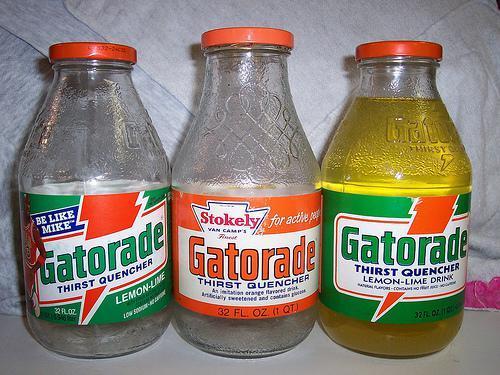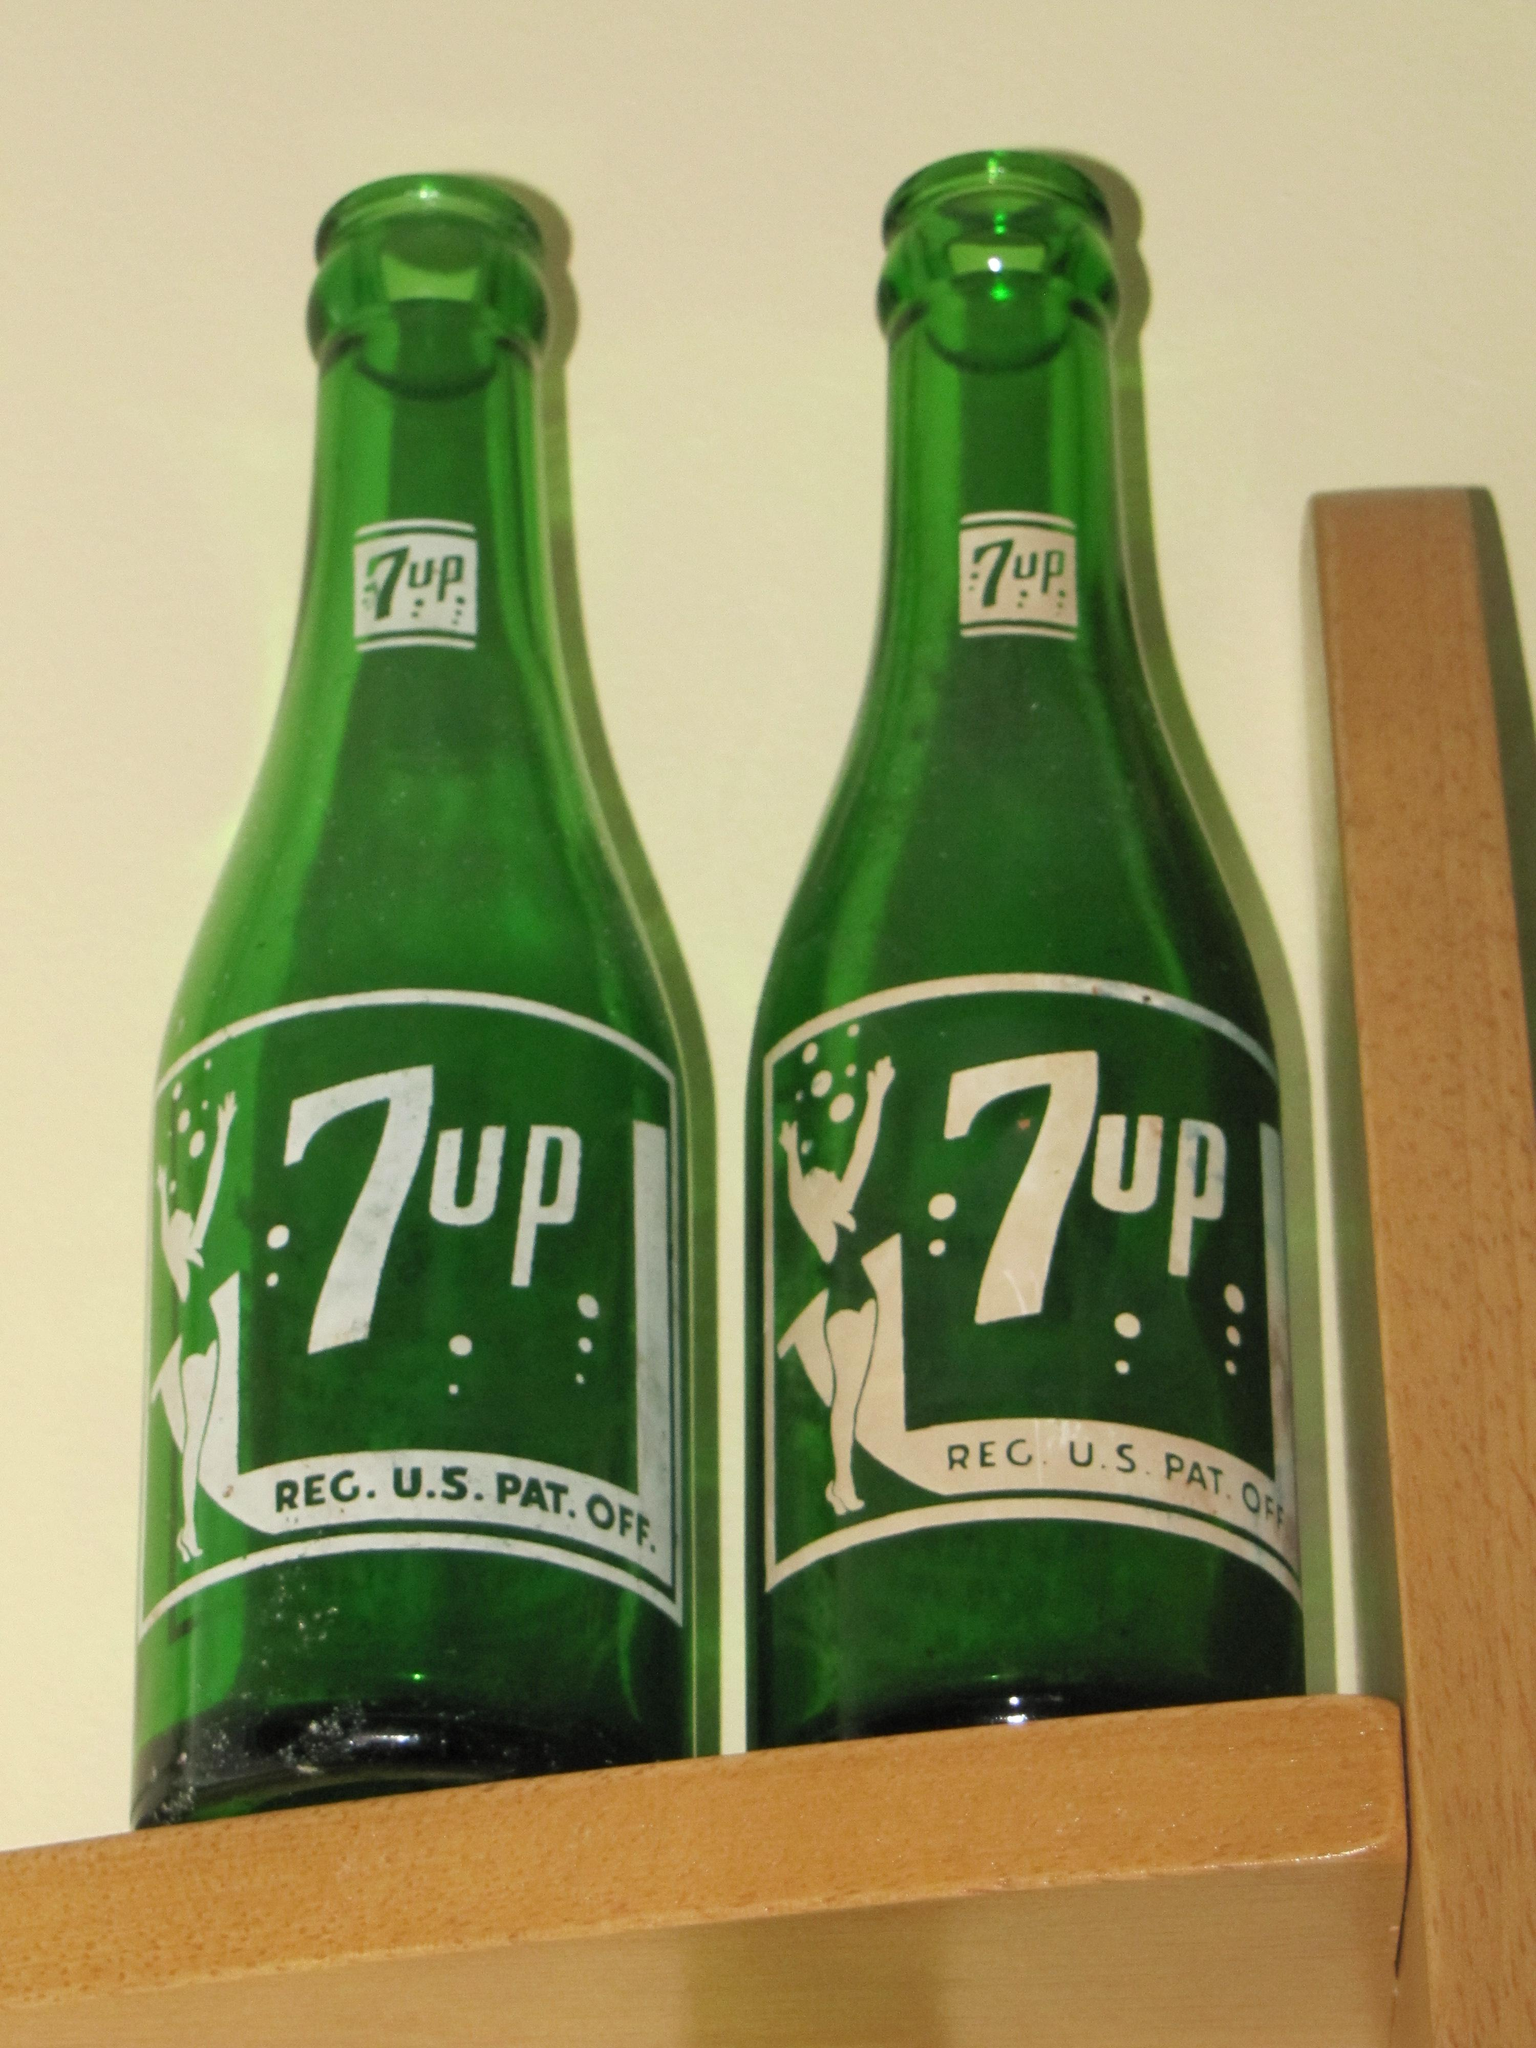The first image is the image on the left, the second image is the image on the right. For the images shown, is this caption "The right image contains two matching green bottles with the same labels, and no image contains cans." true? Answer yes or no. Yes. The first image is the image on the left, the second image is the image on the right. For the images displayed, is the sentence "There are only 7-up bottles in each image." factually correct? Answer yes or no. No. 